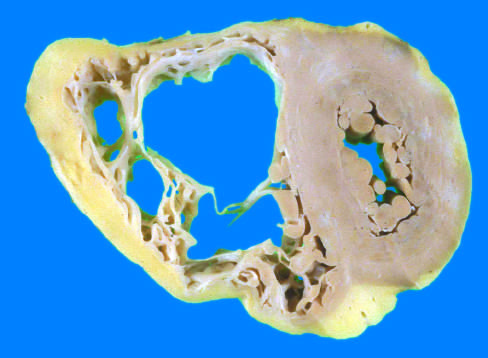does the left ventricle have a grossly normal appearance in this heart?
Answer the question using a single word or phrase. Yes 